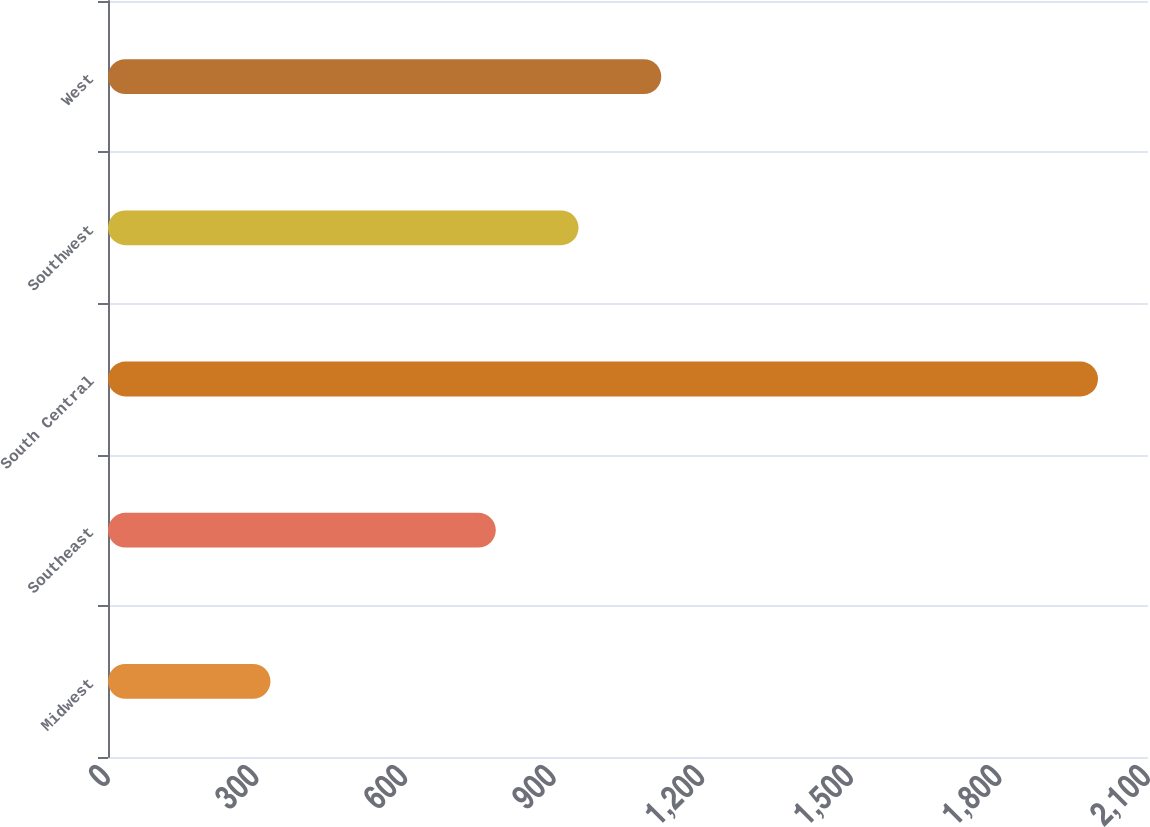Convert chart. <chart><loc_0><loc_0><loc_500><loc_500><bar_chart><fcel>Midwest<fcel>Southeast<fcel>South Central<fcel>Southwest<fcel>West<nl><fcel>328<fcel>783<fcel>1999<fcel>950.1<fcel>1117.2<nl></chart> 